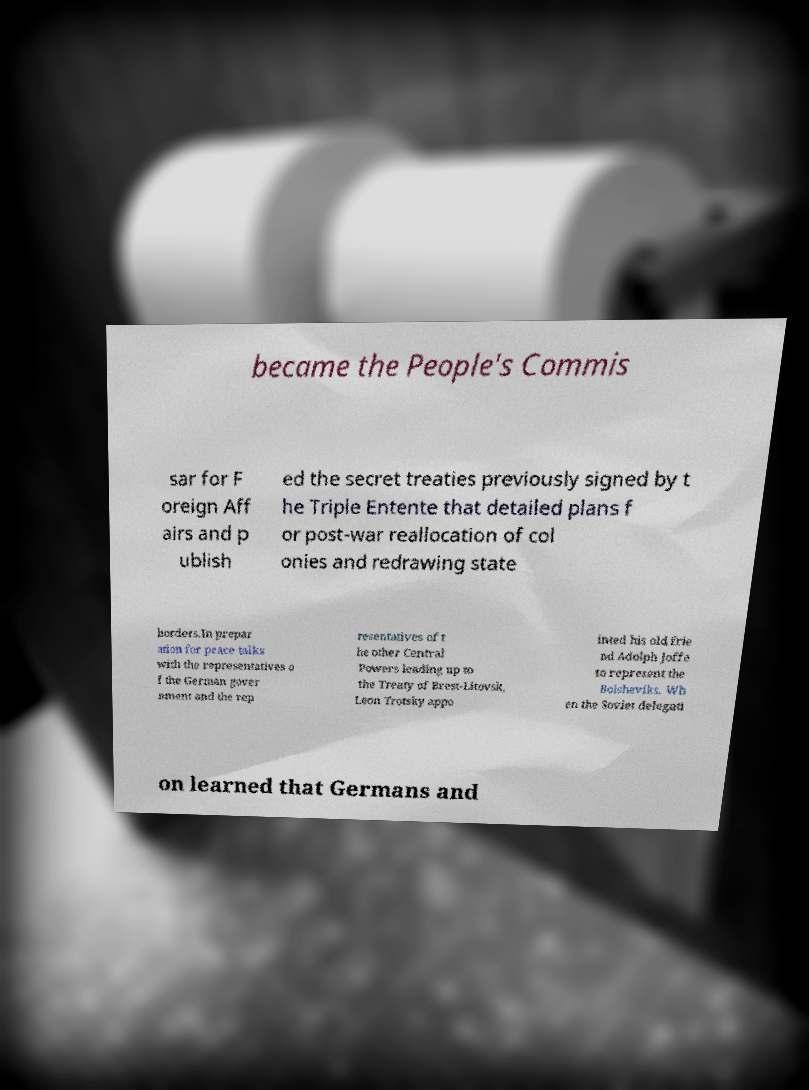Could you extract and type out the text from this image? became the People's Commis sar for F oreign Aff airs and p ublish ed the secret treaties previously signed by t he Triple Entente that detailed plans f or post-war reallocation of col onies and redrawing state borders.In prepar ation for peace talks with the representatives o f the German gover nment and the rep resentatives of t he other Central Powers leading up to the Treaty of Brest-Litovsk, Leon Trotsky appo inted his old frie nd Adolph Joffe to represent the Bolsheviks. Wh en the Soviet delegati on learned that Germans and 